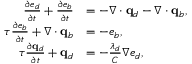Convert formula to latex. <formula><loc_0><loc_0><loc_500><loc_500>\begin{array} { r l } { \frac { \partial e _ { d } } { \partial t } + \frac { \partial e _ { b } } { \partial t } } & { = - \nabla \cdot \mathbf q _ { d } - \nabla \cdot \mathbf q _ { b } , } \\ { \tau \frac { \partial e _ { b } } { \partial t } + \nabla \cdot \mathbf q _ { b } } & { = - e _ { b } , } \\ { \tau \frac { \partial \mathbf q _ { d } } { \partial t } + \mathbf q _ { d } } & { = - \frac { \lambda _ { d } } { C } \nabla e _ { d } , } \end{array}</formula> 